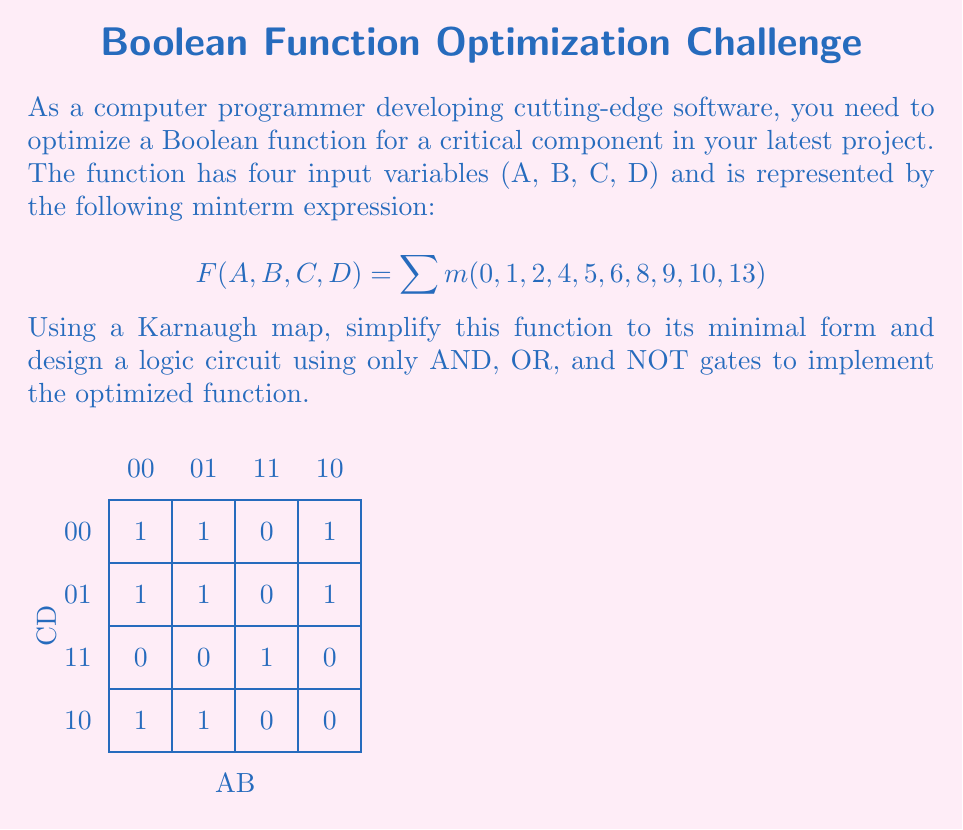What is the answer to this math problem? To optimize the Boolean function using a Karnaugh map and design a logic circuit, we'll follow these steps:

1. Identify groups in the Karnaugh map:
   - Group of 8: 1's in the top two rows (covers minterms 0, 1, 2, 4, 5, 6, 8, 9)
   - Group of 2: 1's in the right column of the second and third rows (covers minterms 9, 13)

2. Write the simplified Boolean expression:
   The groups correspond to the following terms:
   - Group of 8: $\overline{C}$
   - Group of 2: $BD$

   The simplified expression is: $F(A,B,C,D) = \overline{C} + BD$

3. Design the logic circuit:
   - Use a NOT gate for $\overline{C}$
   - Use an AND gate for $BD$
   - Use an OR gate to combine $\overline{C}$ and $BD$

The logic circuit can be represented as follows:

[asy]
unitsize(1cm);

// NOT gate
draw((0,3)--(1,3));
draw((1,2.5)--(1,3.5)--(2,3)--cycle);
draw((2,3)--(3,3));
dot((0,3));
label("C", (-0.5,3));
label("$\overline{C}$", (2.5,3));

// AND gate
draw((0,1)--(2,1));
draw((0,0)--(2,0));
dot((0,1));
dot((0,0));
label("B", (-0.5,1));
label("D", (-0.5,0));
path p = (2,1.5)..(3,0.5)..(2,-0.5);
draw(p);
draw((2,-0.5)--(2,1.5));
draw((3,0.5)--(4,0.5));

// OR gate
path q = (4,3)..(5,1.75)..(6,1.75);
path r = (4,0.5)..(5,1.75)..(6,1.75);
draw(q);
draw(r);
draw((4,3)--(4,0.5));
draw((6,1.75)--(7,1.75));

label("F", (7.5,1.75));
[/asy]

This circuit implements the optimized Boolean function $F(A,B,C,D) = \overline{C} + BD$ using only AND, OR, and NOT gates.
Answer: $F(A,B,C,D) = \overline{C} + BD$ 